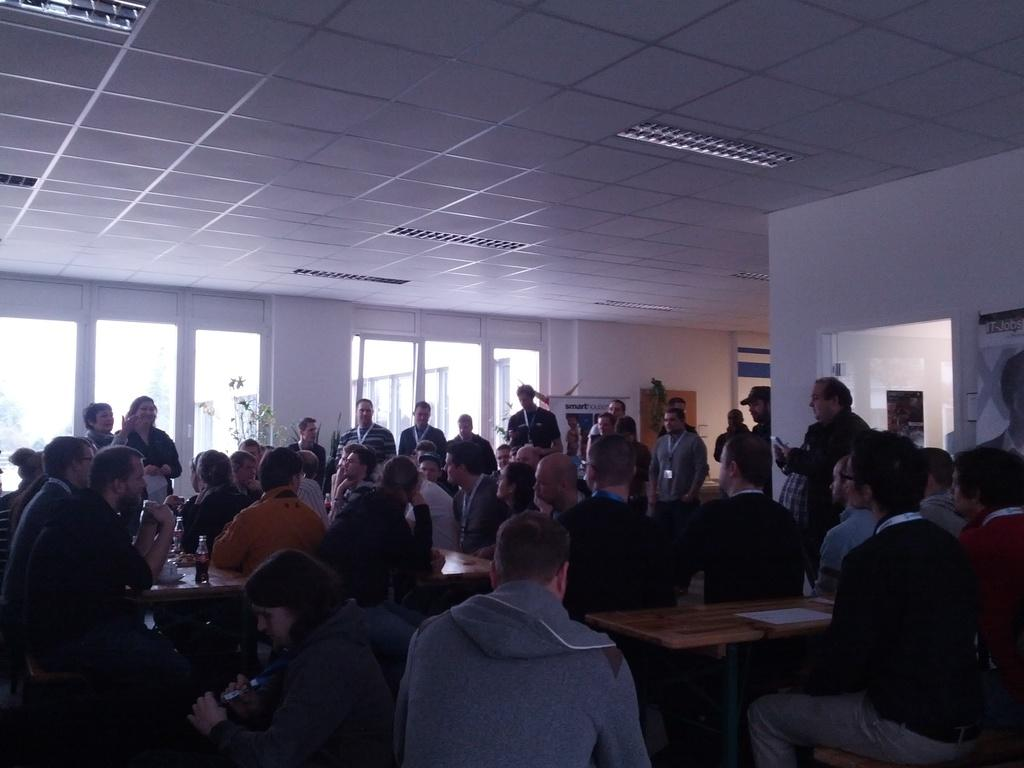Who or what is present in the image? There are people in the image. What object can be seen in the image that might be used for eating or working? There is a table in the image. What color is the roof in the image? The roof in the image is white. Can you hear the sound of a rifle in the image? There is no sound or rifle present in the image. What type of scissors can be seen being used by the people in the image? There are no scissors visible in the image. 